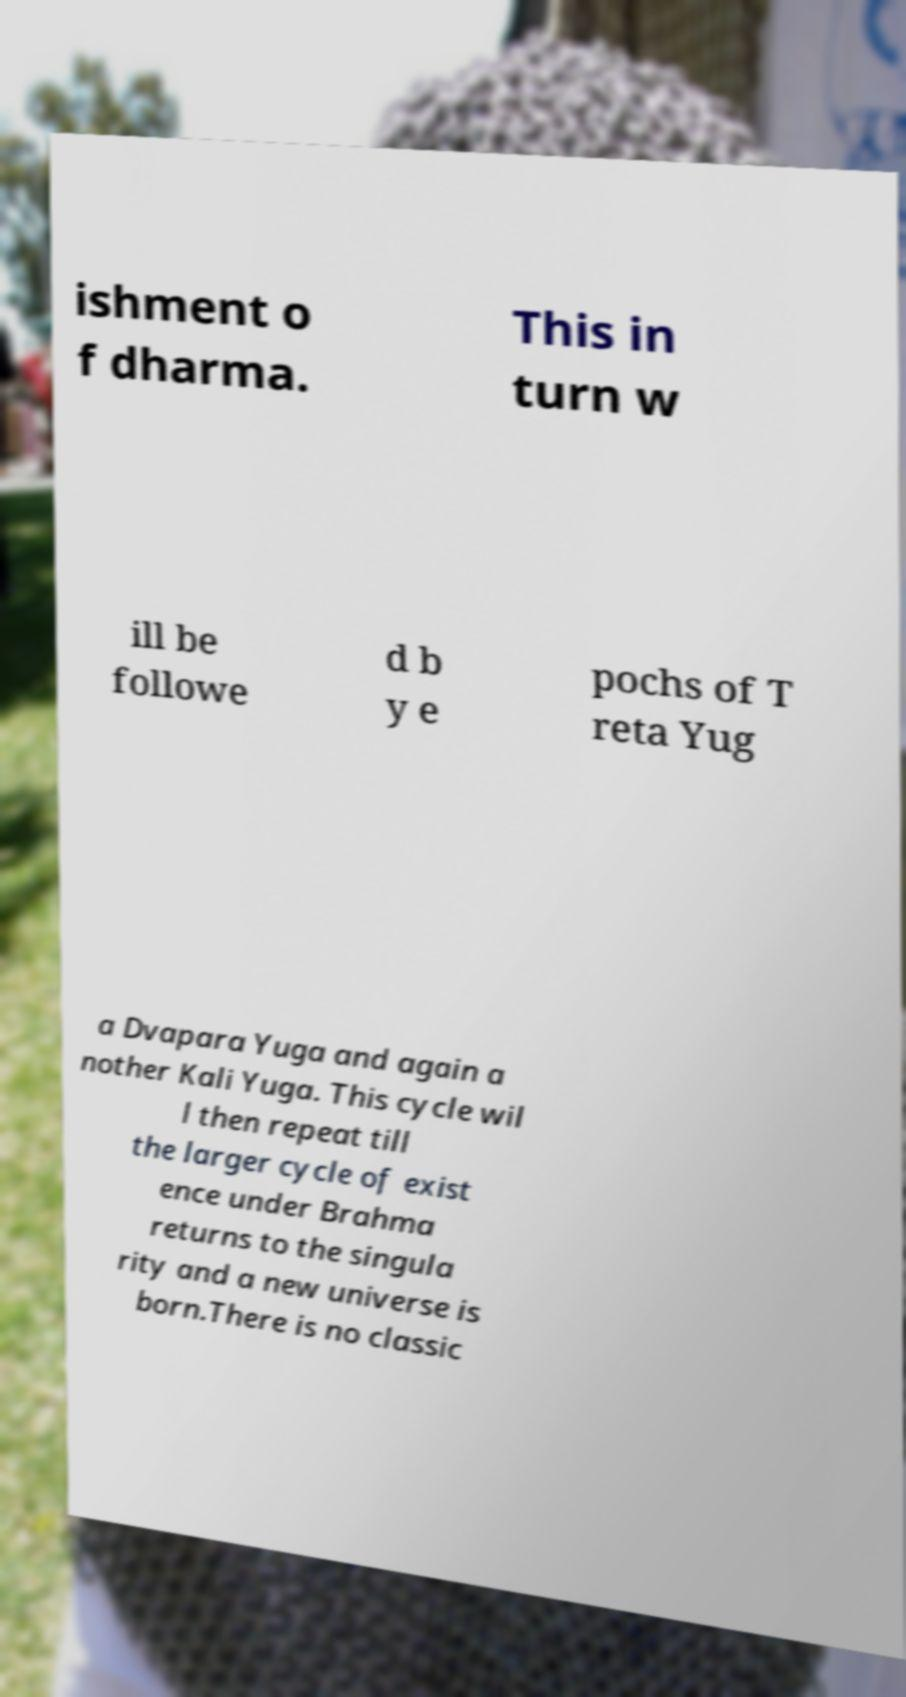Please read and relay the text visible in this image. What does it say? ishment o f dharma. This in turn w ill be followe d b y e pochs of T reta Yug a Dvapara Yuga and again a nother Kali Yuga. This cycle wil l then repeat till the larger cycle of exist ence under Brahma returns to the singula rity and a new universe is born.There is no classic 